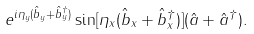Convert formula to latex. <formula><loc_0><loc_0><loc_500><loc_500>e ^ { i \eta _ { y } ( \hat { b } _ { y } + \hat { b } _ { y } ^ { \dagger } ) } \sin [ \eta _ { x } ( \hat { b } _ { x } + \hat { b } _ { x } ^ { \dagger } ) ] ( \hat { a } + \hat { a } ^ { \dagger } ) .</formula> 